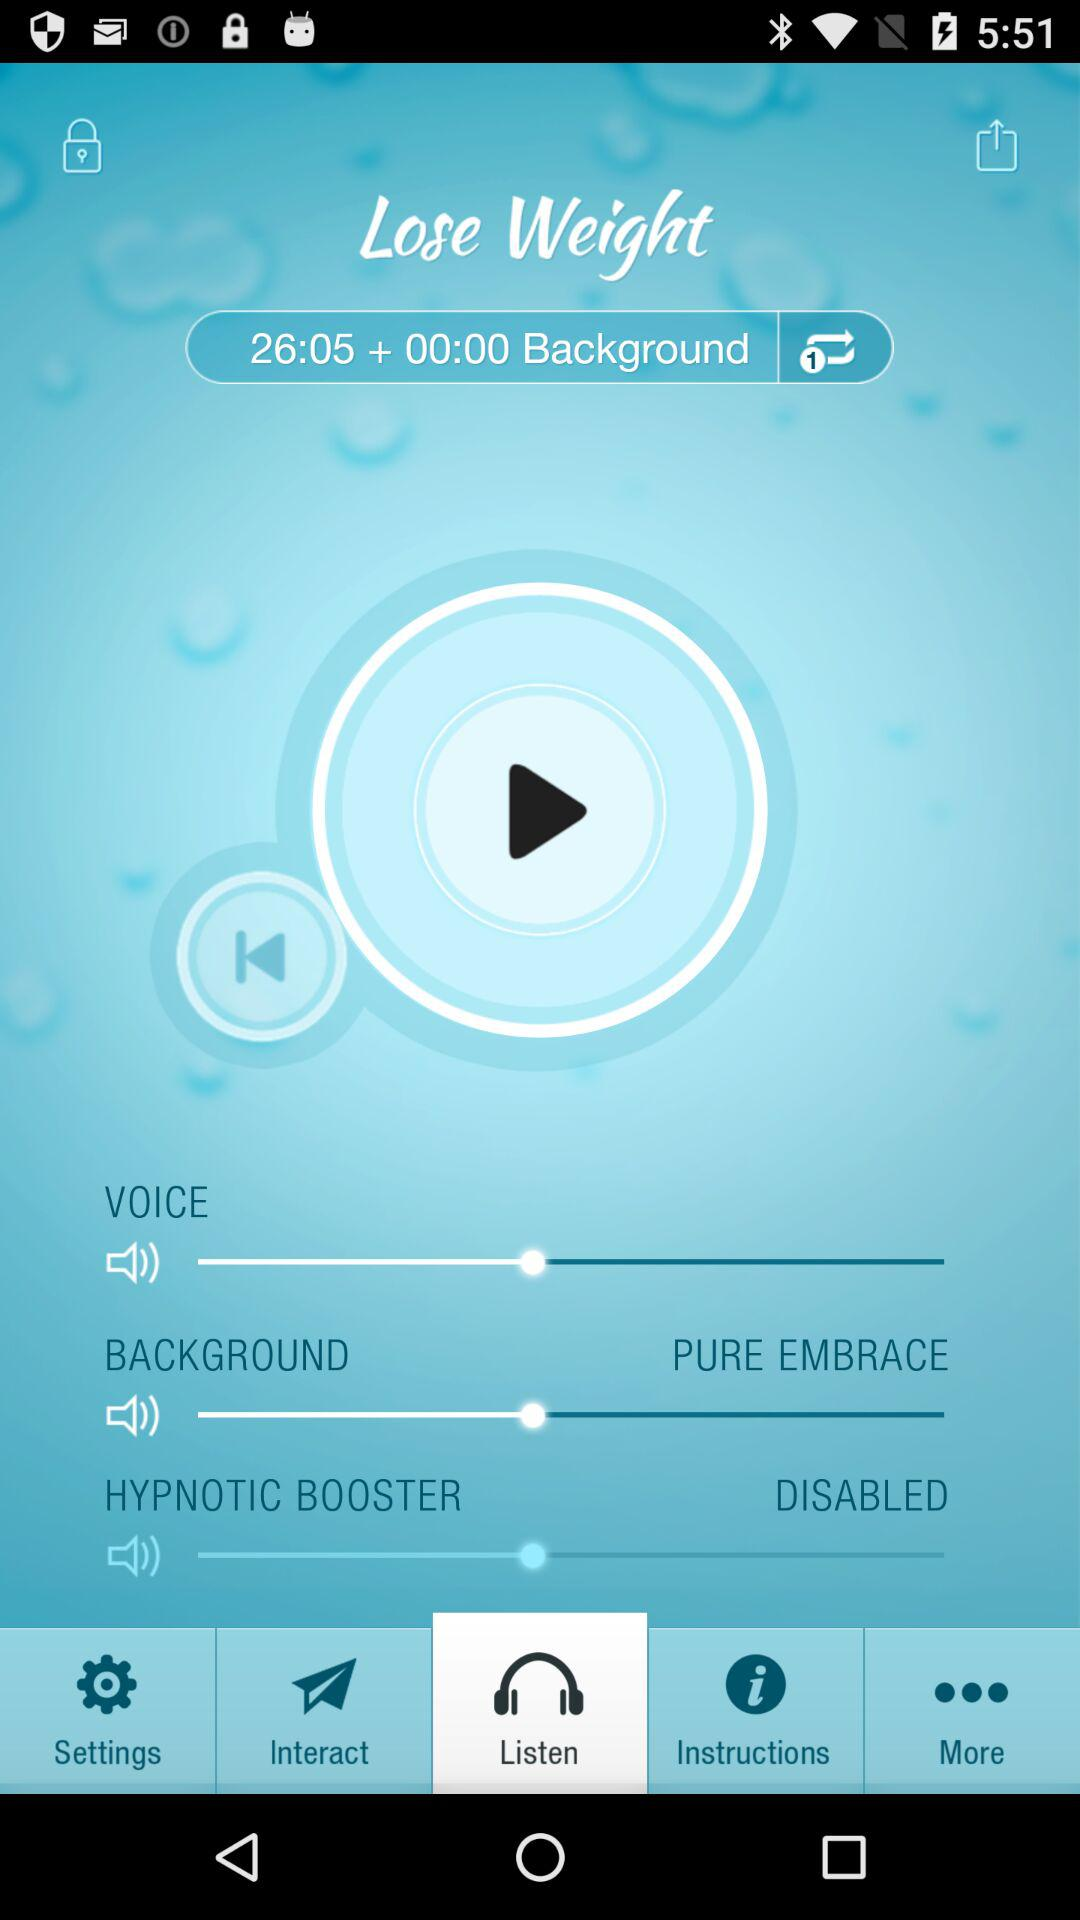What is the current status of the "HYPNOTIC BOOSTER"? The current status of the "HYPNOTIC BOOSTER" is "disabled". 